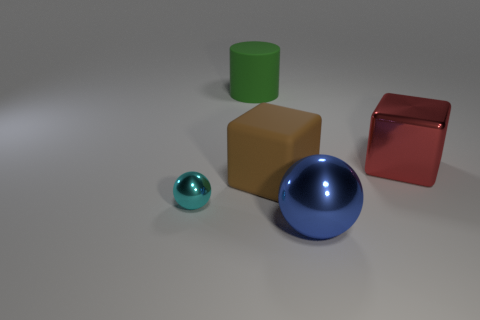Is there anything else that has the same size as the cyan metal sphere?
Provide a succinct answer. No. What is the color of the block that is left of the metal block?
Offer a very short reply. Brown. What number of metal objects are either brown cubes or small balls?
Provide a succinct answer. 1. What number of cyan metallic spheres are the same size as the cyan metal thing?
Offer a terse response. 0. There is a thing that is both behind the tiny cyan thing and in front of the red object; what color is it?
Provide a succinct answer. Brown. How many things are either tiny yellow matte spheres or big cylinders?
Your answer should be compact. 1. What number of big objects are spheres or gray rubber objects?
Your answer should be very brief. 1. How big is the thing that is both left of the blue metallic sphere and behind the rubber cube?
Provide a short and direct response. Large. There is a metallic thing that is right of the large blue object; does it have the same color as the shiny ball that is to the right of the cyan sphere?
Give a very brief answer. No. How many other things are there of the same material as the cyan sphere?
Make the answer very short. 2. 